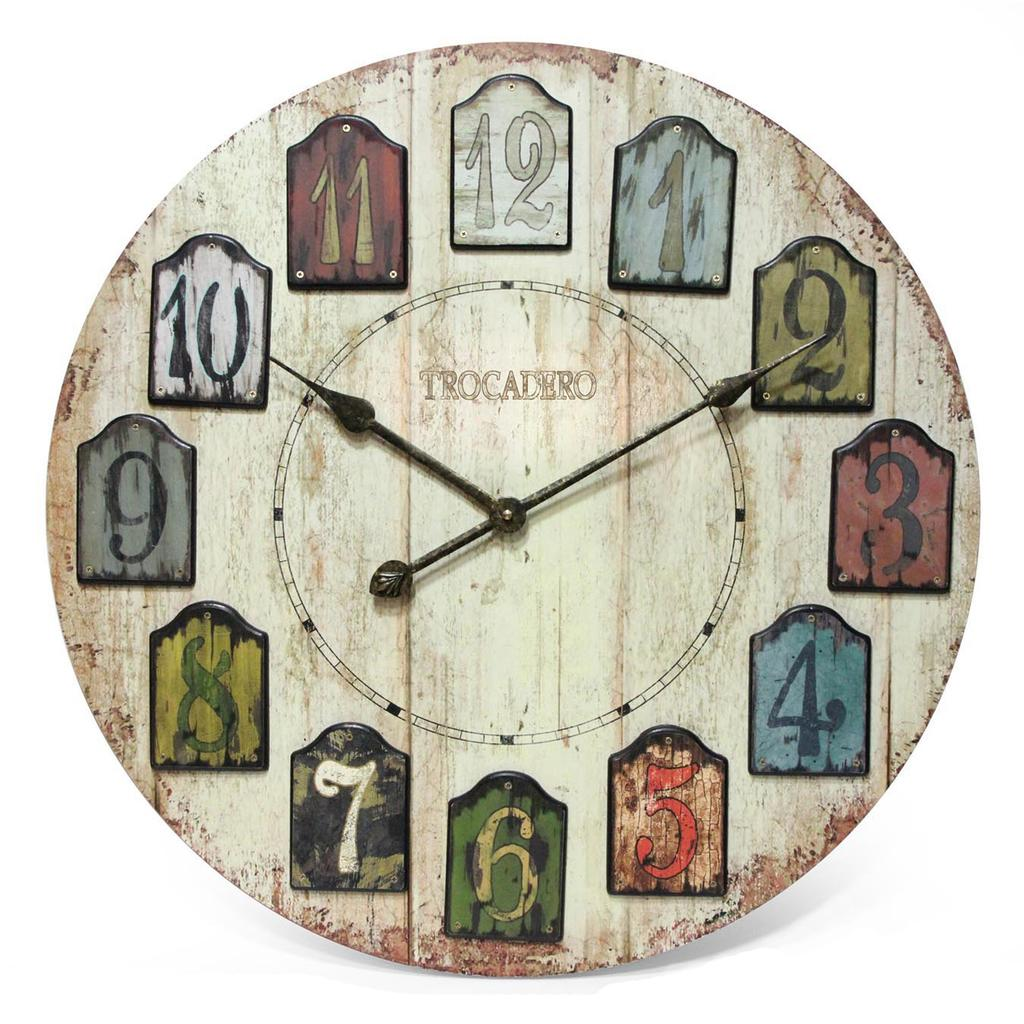Provide a one-sentence caption for the provided image. a Trocadero analog clock with weather beaten numbers. 